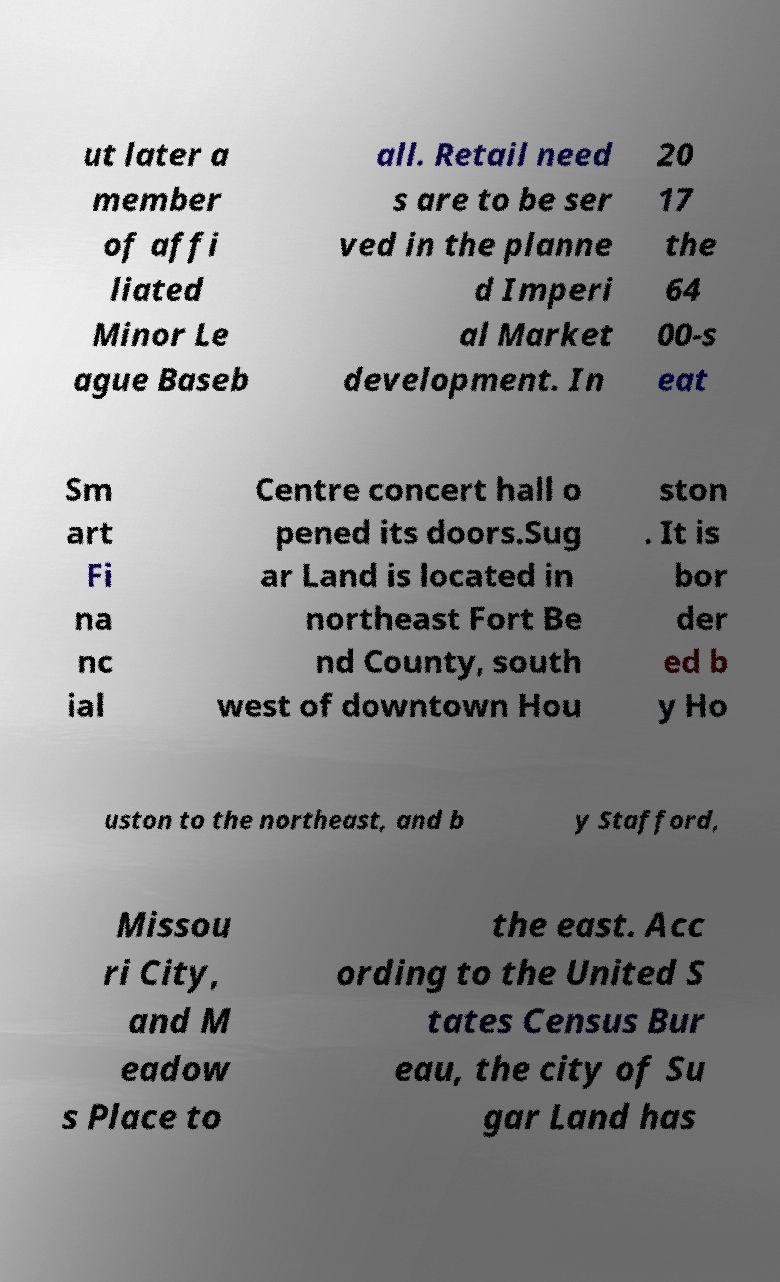For documentation purposes, I need the text within this image transcribed. Could you provide that? ut later a member of affi liated Minor Le ague Baseb all. Retail need s are to be ser ved in the planne d Imperi al Market development. In 20 17 the 64 00-s eat Sm art Fi na nc ial Centre concert hall o pened its doors.Sug ar Land is located in northeast Fort Be nd County, south west of downtown Hou ston . It is bor der ed b y Ho uston to the northeast, and b y Stafford, Missou ri City, and M eadow s Place to the east. Acc ording to the United S tates Census Bur eau, the city of Su gar Land has 